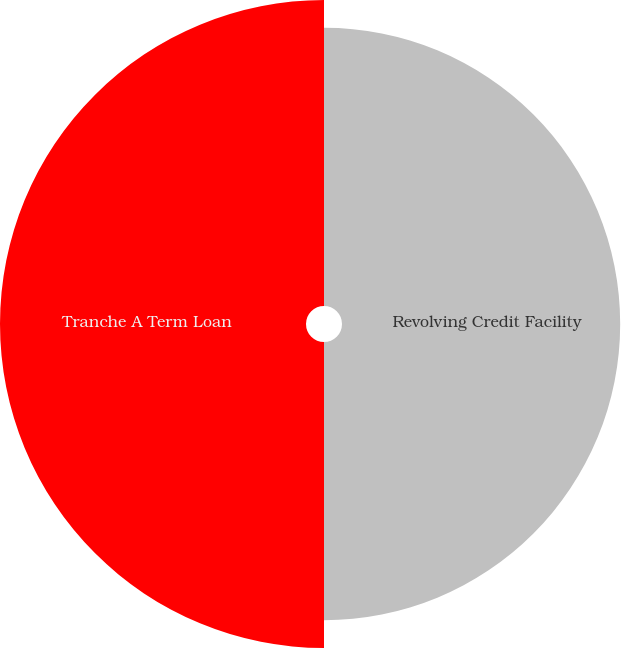Convert chart. <chart><loc_0><loc_0><loc_500><loc_500><pie_chart><fcel>Revolving Credit Facility<fcel>Tranche A Term Loan<nl><fcel>47.62%<fcel>52.38%<nl></chart> 